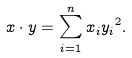<formula> <loc_0><loc_0><loc_500><loc_500>x \cdot y = \sum _ { i = 1 } ^ { n } x _ { i } { y _ { i } } ^ { 2 } .</formula> 